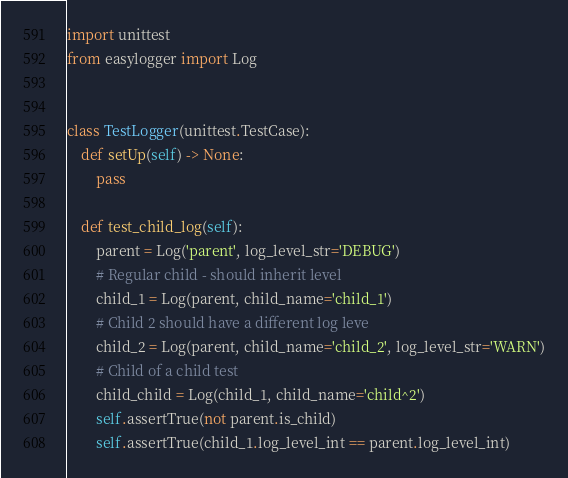Convert code to text. <code><loc_0><loc_0><loc_500><loc_500><_Python_>import unittest
from easylogger import Log


class TestLogger(unittest.TestCase):
    def setUp(self) -> None:
        pass

    def test_child_log(self):
        parent = Log('parent', log_level_str='DEBUG')
        # Regular child - should inherit level
        child_1 = Log(parent, child_name='child_1')
        # Child 2 should have a different log leve
        child_2 = Log(parent, child_name='child_2', log_level_str='WARN')
        # Child of a child test
        child_child = Log(child_1, child_name='child^2')
        self.assertTrue(not parent.is_child)
        self.assertTrue(child_1.log_level_int == parent.log_level_int)</code> 